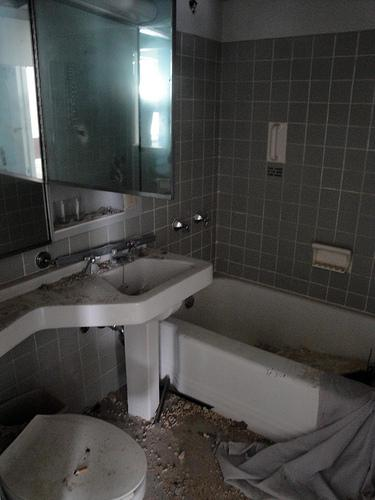Question: who is in the picture?
Choices:
A. No one.
B. A woman wearing a blue hat.
C. A man wearing glasses.
D. A guy surfing.
Answer with the letter. Answer: A Question: where was the picture taken?
Choices:
A. Bathroom.
B. At the beach.
C. At the zoo.
D. At a museum.
Answer with the letter. Answer: A Question: how many tubs are visible?
Choices:
A. Two.
B. Five.
C. Four.
D. One.
Answer with the letter. Answer: D Question: what color are the tiles on the wall?
Choices:
A. Red.
B. Black.
C. Gray.
D. White.
Answer with the letter. Answer: C Question: what are the two objects on the shelf above the sink?
Choices:
A. Toothbrushes.
B. Medicine bottles.
C. Bars of soap.
D. Glasses.
Answer with the letter. Answer: D Question: what state is the bathroom in, good or bad?
Choices:
A. Dirty.
B. Clean.
C. Sanitized.
D. Bad.
Answer with the letter. Answer: D 